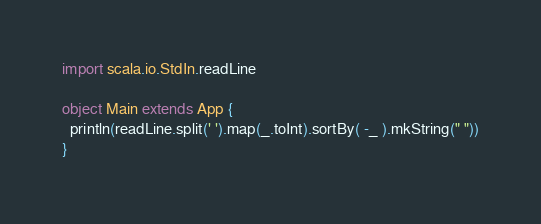Convert code to text. <code><loc_0><loc_0><loc_500><loc_500><_Scala_>import scala.io.StdIn.readLine

object Main extends App {
  println(readLine.split(' ').map(_.toInt).sortBy( -_ ).mkString(" "))
}</code> 